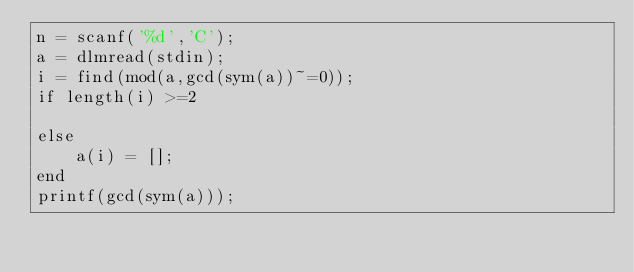<code> <loc_0><loc_0><loc_500><loc_500><_Octave_>n = scanf('%d','C');
a = dlmread(stdin);
i = find(mod(a,gcd(sym(a))~=0));
if length(i) >=2

else
	a(i) = [];
end
printf(gcd(sym(a)));
</code> 